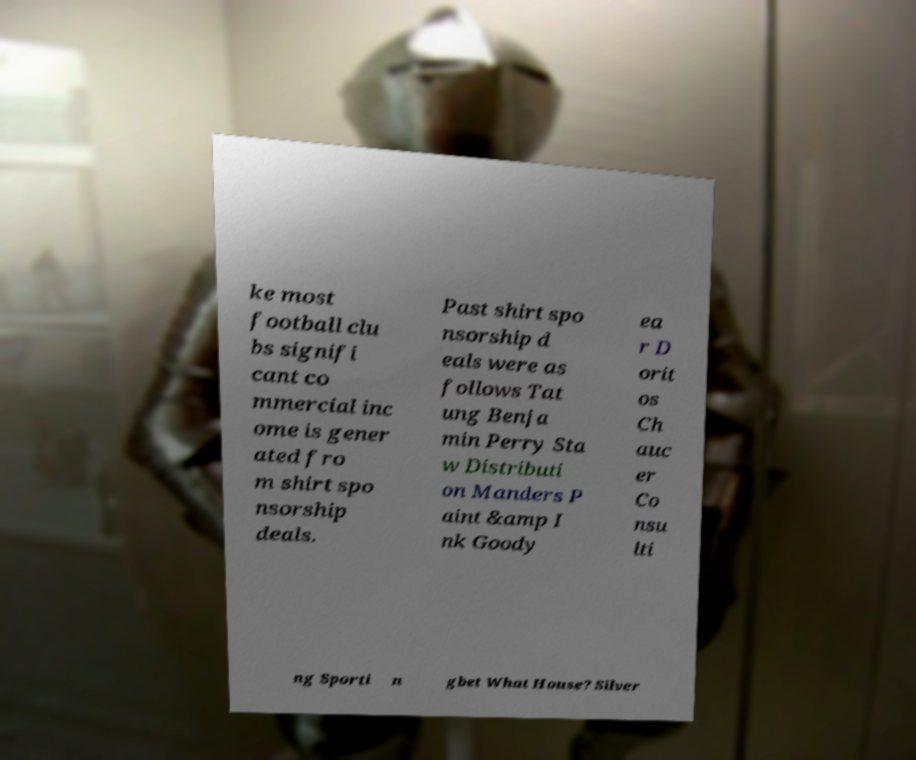What messages or text are displayed in this image? I need them in a readable, typed format. ke most football clu bs signifi cant co mmercial inc ome is gener ated fro m shirt spo nsorship deals. Past shirt spo nsorship d eals were as follows Tat ung Benja min Perry Sta w Distributi on Manders P aint &amp I nk Goody ea r D orit os Ch auc er Co nsu lti ng Sporti n gbet What House? Silver 